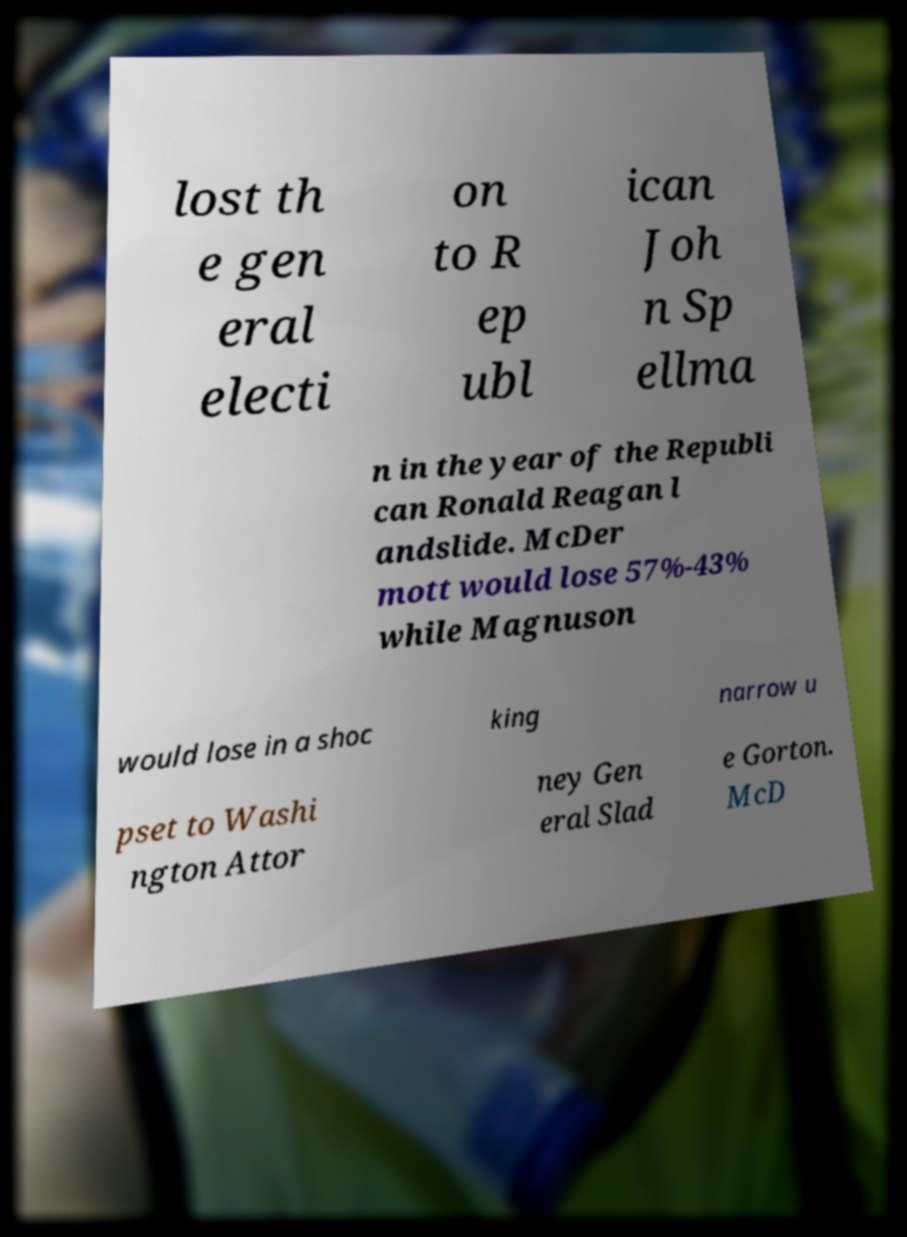What messages or text are displayed in this image? I need them in a readable, typed format. lost th e gen eral electi on to R ep ubl ican Joh n Sp ellma n in the year of the Republi can Ronald Reagan l andslide. McDer mott would lose 57%-43% while Magnuson would lose in a shoc king narrow u pset to Washi ngton Attor ney Gen eral Slad e Gorton. McD 